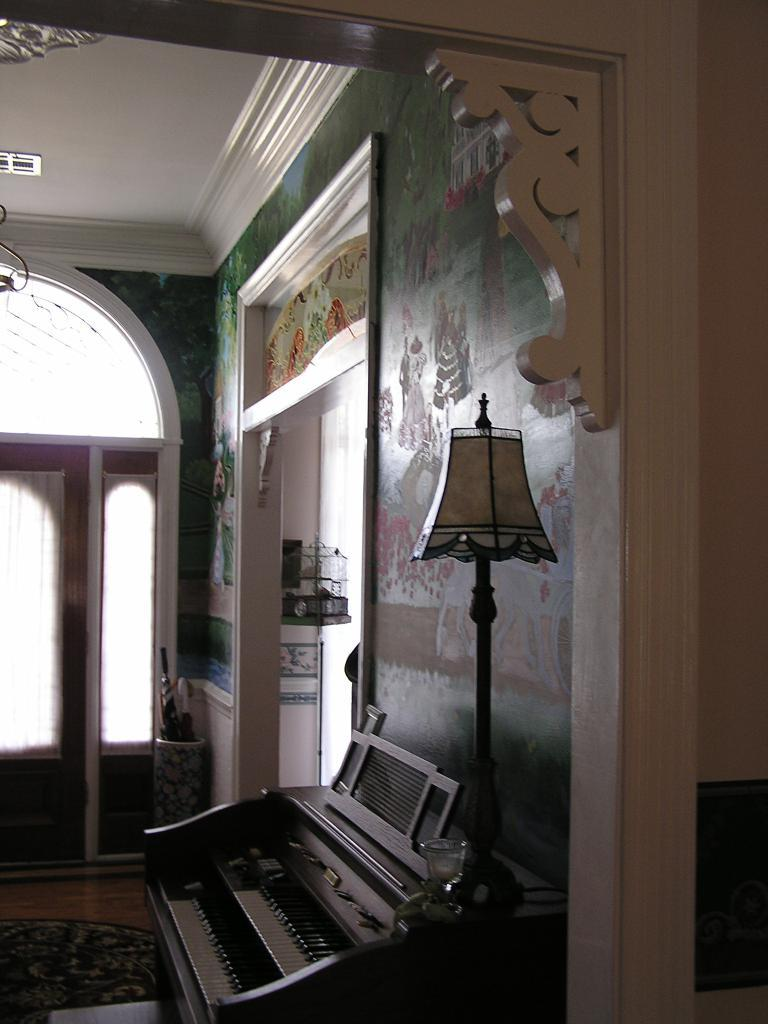What musical instrument is present in the image? There is a piano in the image. What is another object that can be seen in the image? There is a lamp in the image. What feature of the room is visible in the image? There is a window in the room. How many feet are visible on the piano in the image? There are no feet visible on the piano in the image, as it is a musical instrument and not a person or animal. What type of star can be seen shining through the window in the image? There is no star visible through the window in the image; only the piano, lamp, and window are present. 